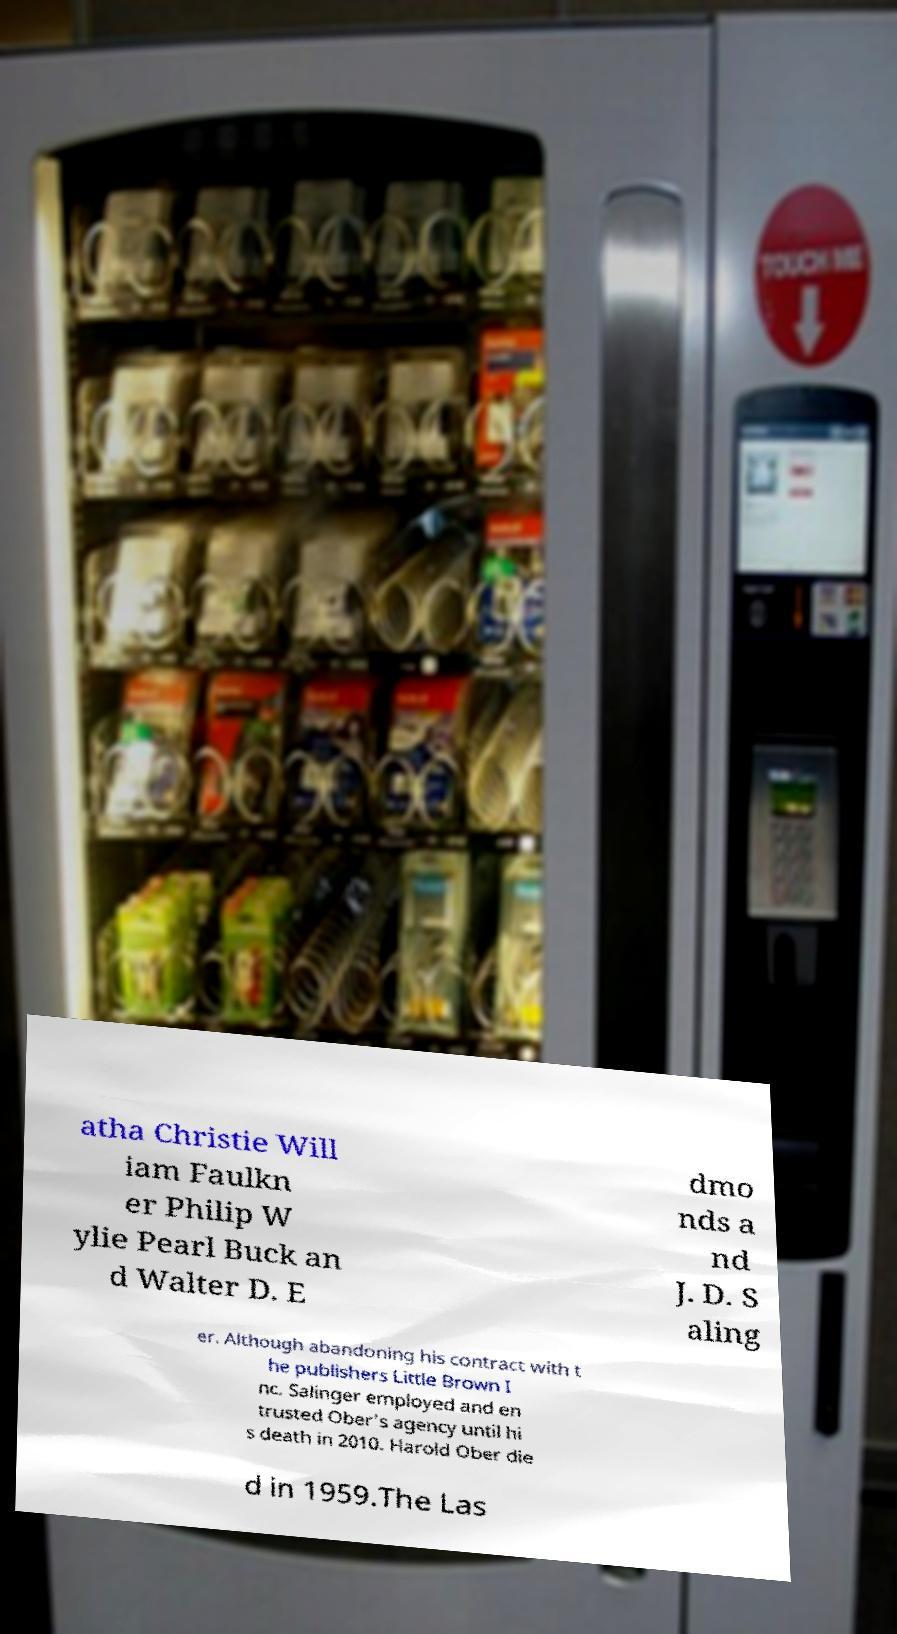Can you accurately transcribe the text from the provided image for me? atha Christie Will iam Faulkn er Philip W ylie Pearl Buck an d Walter D. E dmo nds a nd J. D. S aling er. Although abandoning his contract with t he publishers Little Brown I nc. Salinger employed and en trusted Ober's agency until hi s death in 2010. Harold Ober die d in 1959.The Las 